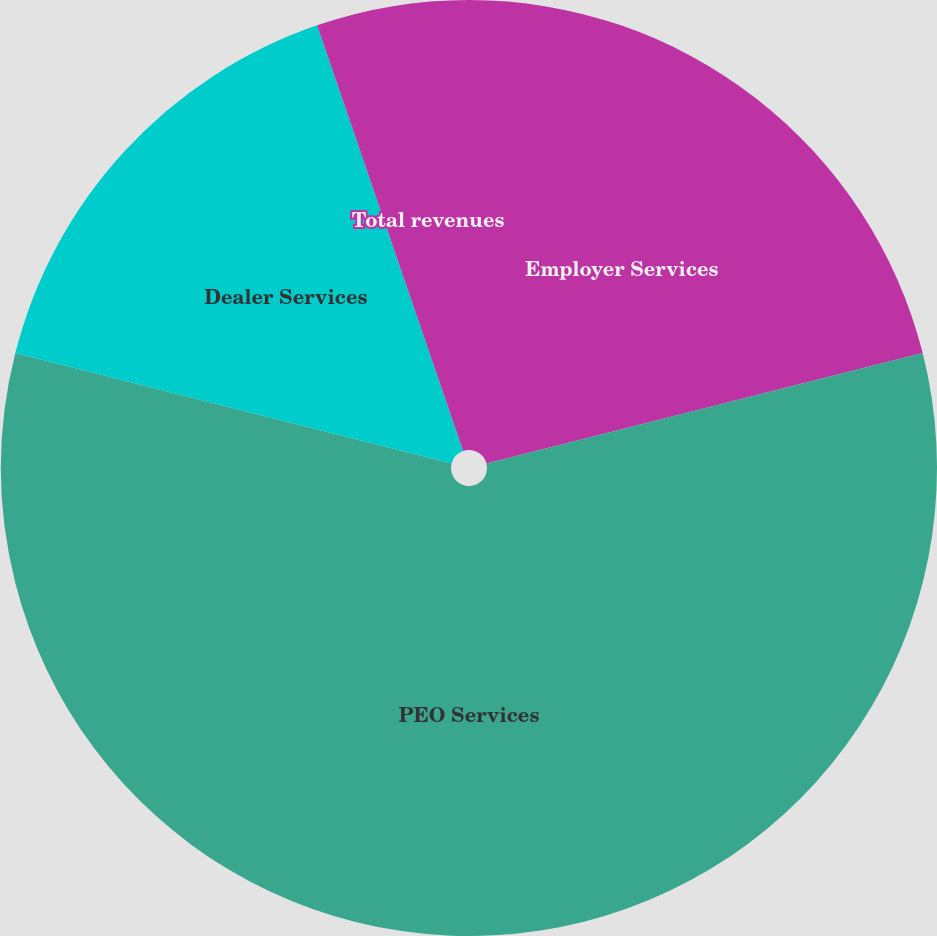Convert chart. <chart><loc_0><loc_0><loc_500><loc_500><pie_chart><fcel>Employer Services<fcel>PEO Services<fcel>Dealer Services<fcel>Total revenues<nl><fcel>21.05%<fcel>57.89%<fcel>15.79%<fcel>5.26%<nl></chart> 